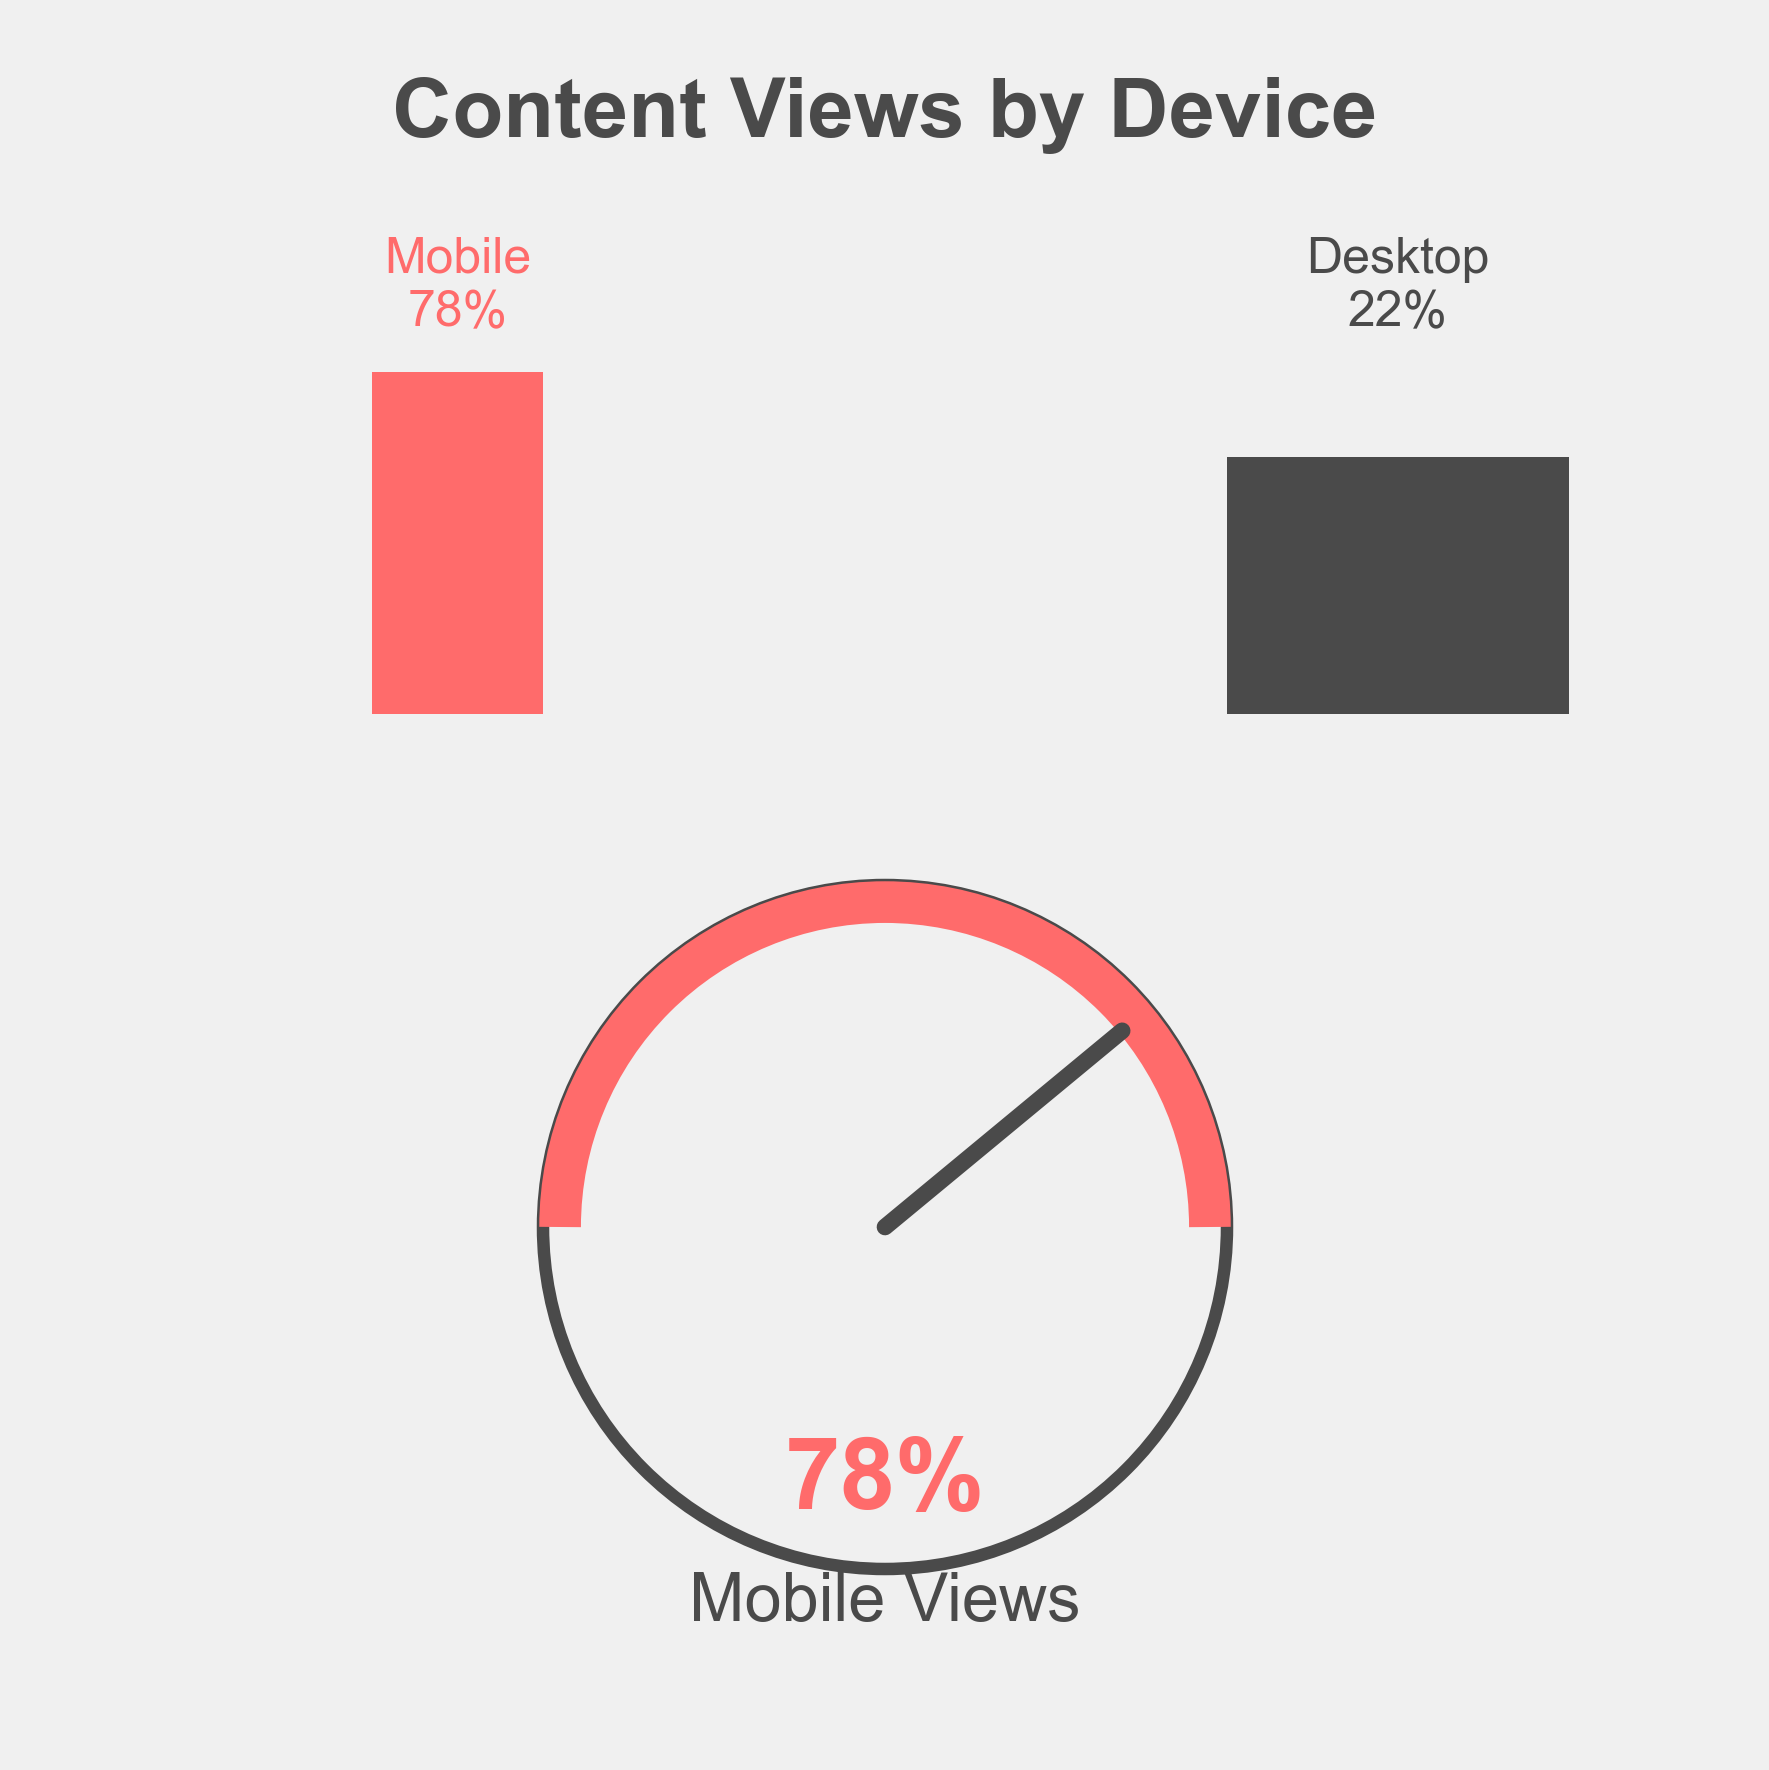what is the title of the figure? The title of a figure is typically displayed at the top, often in a larger font size and bold to stand out. In this figure, the title reads "Content Views by Device."
Answer: Content Views by Device How many device types are shown in the figure? Looking at the icons and labels present in the figure, we can see two different device types, represented by rectangles labeled "Mobile" and "Desktop."
Answer: Two What percentage of content views come from mobile devices? The figure highlights a large percentage text and a gauge needle pointing to the mobile section. The text explicitly states "78%" for mobile views.
Answer: 78% Which device type has fewer content views? By comparing the percentages given for mobile and desktop views, we see that desktop views are 22%, which is less than the 78% for mobile views.
Answer: Desktop What does the needle on the gauge indicate? The needle in a gauge chart typically indicates a numerical value. Here, it points towards the mobile section, which is also reinforced by the large percentage text showing 78%.
Answer: Mobile views How much more content is viewed on mobile devices compared to desktop devices? To find the difference, subtract the desktop percentage from the mobile percentage: 78% (mobile) - 22% (desktop) = 56%.
Answer: 56% What percentage of content views come from desktop devices? The figure presents a rectangular icon for desktop with accompanying text that clearly states the desktop view percentage, which is 22%.
Answer: 22% Are more than half of the content views from mobile devices? A value greater than 50% would mean more than half. The figure shows mobile views at 78%, which is greater than 50%.
Answer: Yes Is the needle on the gauge closer to the 'Mobile Views' or the 'Desktop Views'? In a gauge chart, the closer the needle is to a section, the higher the value it represents for that section. Here, the needle leans much closer to the 'Mobile Views' side.
Answer: Mobile Views What does the large percentage text below the needle represent? The percentage text below the needle aligns with the value the needle is pointing to, which is '78%' for mobile views. This text clarifies and highlights that 78% of the content views are from mobile devices.
Answer: Mobile views, 78% 